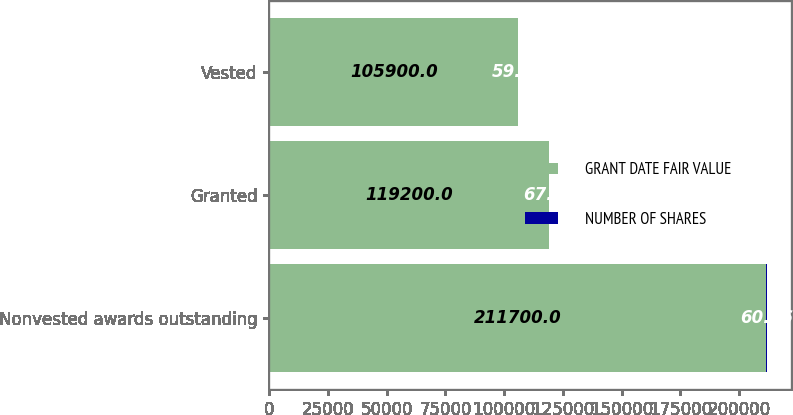Convert chart to OTSL. <chart><loc_0><loc_0><loc_500><loc_500><stacked_bar_chart><ecel><fcel>Nonvested awards outstanding<fcel>Granted<fcel>Vested<nl><fcel>GRANT DATE FAIR VALUE<fcel>211700<fcel>119200<fcel>105900<nl><fcel>NUMBER OF SHARES<fcel>60.16<fcel>67.48<fcel>59.24<nl></chart> 